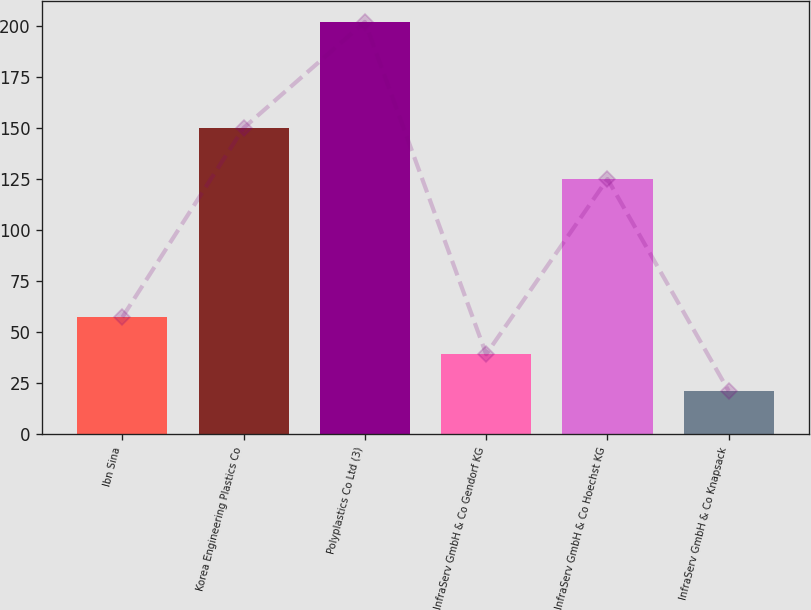Convert chart to OTSL. <chart><loc_0><loc_0><loc_500><loc_500><bar_chart><fcel>Ibn Sina<fcel>Korea Engineering Plastics Co<fcel>Polyplastics Co Ltd (3)<fcel>InfraServ GmbH & Co Gendorf KG<fcel>InfraServ GmbH & Co Hoechst KG<fcel>InfraServ GmbH & Co Knapsack<nl><fcel>57.2<fcel>150<fcel>202<fcel>39.1<fcel>125<fcel>21<nl></chart> 